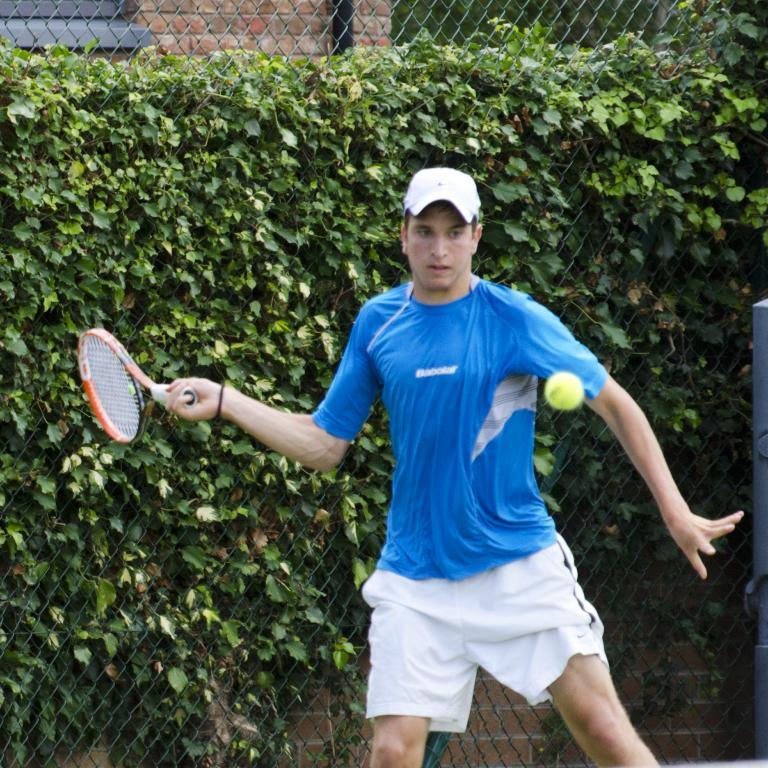Who is present in the image? There is a man in the image. What is the man wearing? The man is wearing a blue T-shirt and a cap. What is the man holding in his hand? The man is holding a tennis racket in his hand. What is the man trying to do in the image? The man is trying to hit a ball. What can be seen in the background of the image? There is a tree and a net in the background of the image. What is the man's desire to experience hearing in the image? There is no mention of the man's desire or experience of hearing in the image. The focus is on the man, his clothing, the object he is holding, his action, and the background elements. 